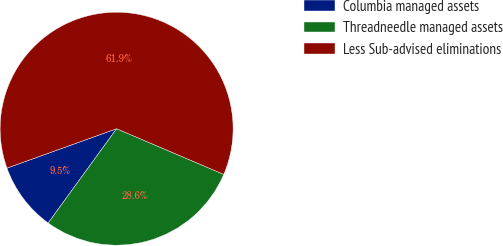<chart> <loc_0><loc_0><loc_500><loc_500><pie_chart><fcel>Columbia managed assets<fcel>Threadneedle managed assets<fcel>Less Sub-advised eliminations<nl><fcel>9.52%<fcel>28.57%<fcel>61.9%<nl></chart> 